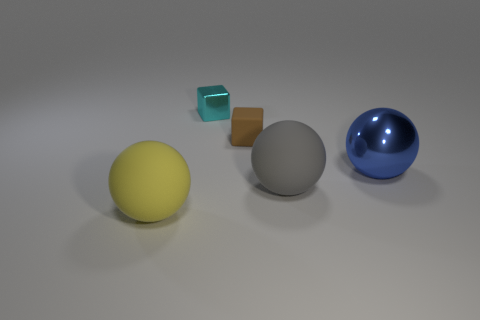Subtract all big yellow rubber balls. How many balls are left? 2 Add 3 yellow rubber objects. How many objects exist? 8 Subtract all blocks. How many objects are left? 3 Subtract all gray balls. Subtract all gray blocks. How many balls are left? 2 Subtract all small brown things. Subtract all small brown cubes. How many objects are left? 3 Add 1 small cyan blocks. How many small cyan blocks are left? 2 Add 3 green metallic blocks. How many green metallic blocks exist? 3 Subtract 0 yellow cubes. How many objects are left? 5 